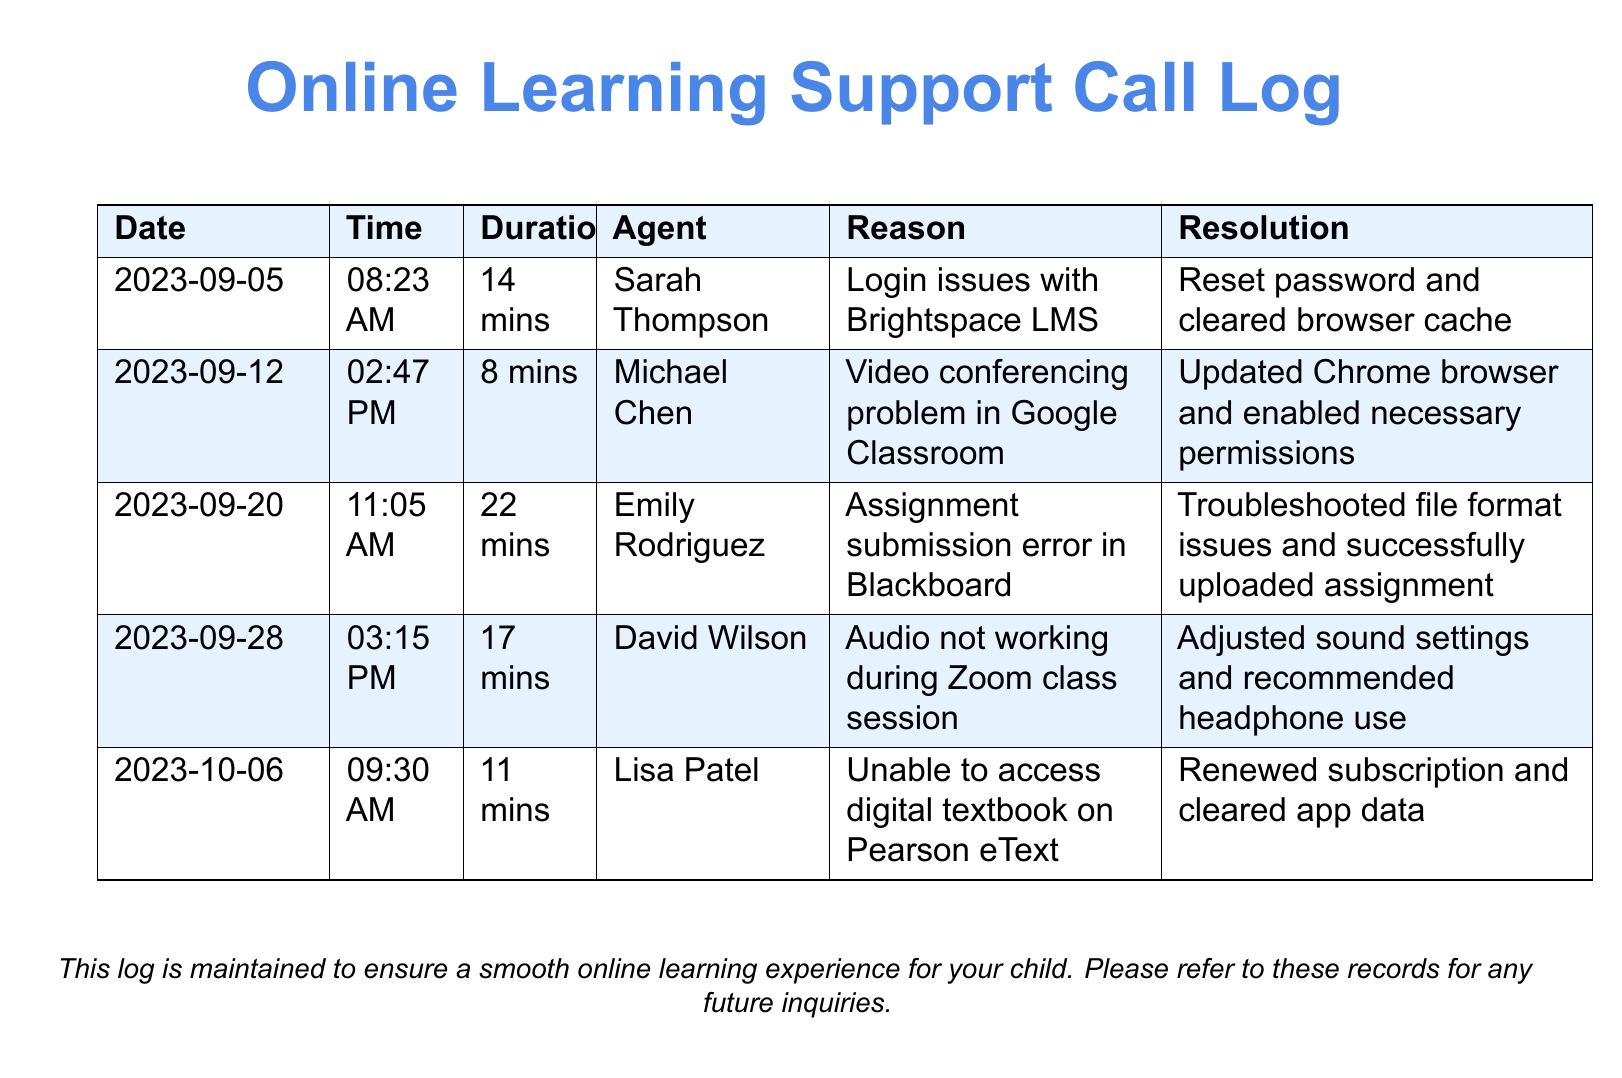What date did the first call take place? The first call in the log was made on 2023-09-05 according to the date listed in the table.
Answer: 2023-09-05 Who was the agent on the call regarding audio issues? The call regarding audio not working during Zoom was handled by David Wilson.
Answer: David Wilson What was the duration of the longest call? The longest call in the log lasted 22 minutes, which can be found in the duration column of the third entry.
Answer: 22 mins How many times did the support involve troubleshooting issues with submission? There is one instance of troubleshooting issues with assignment submission, as noted in the entry dated 2023-09-20.
Answer: 1 time What issue was resolved on October 6th? The call on October 6th dealt with accessing the digital textbook on Pearson eText, as stated in the reason column of that entry.
Answer: Unable to access digital textbook What was a common theme in the call reasons? The reasons for the calls often revolved around technical issues related to online learning platforms.
Answer: Technical issues Which online platform was mentioned for the assignment submission error? The platform mentioned for the assignment submission error is Blackboard, indicated in the specific entry of the log.
Answer: Blackboard How many times were browser-related issues mentioned? Browser-related issues were mentioned in two calls: one for Brightspace LMS and one for Google Classroom.
Answer: 2 times 